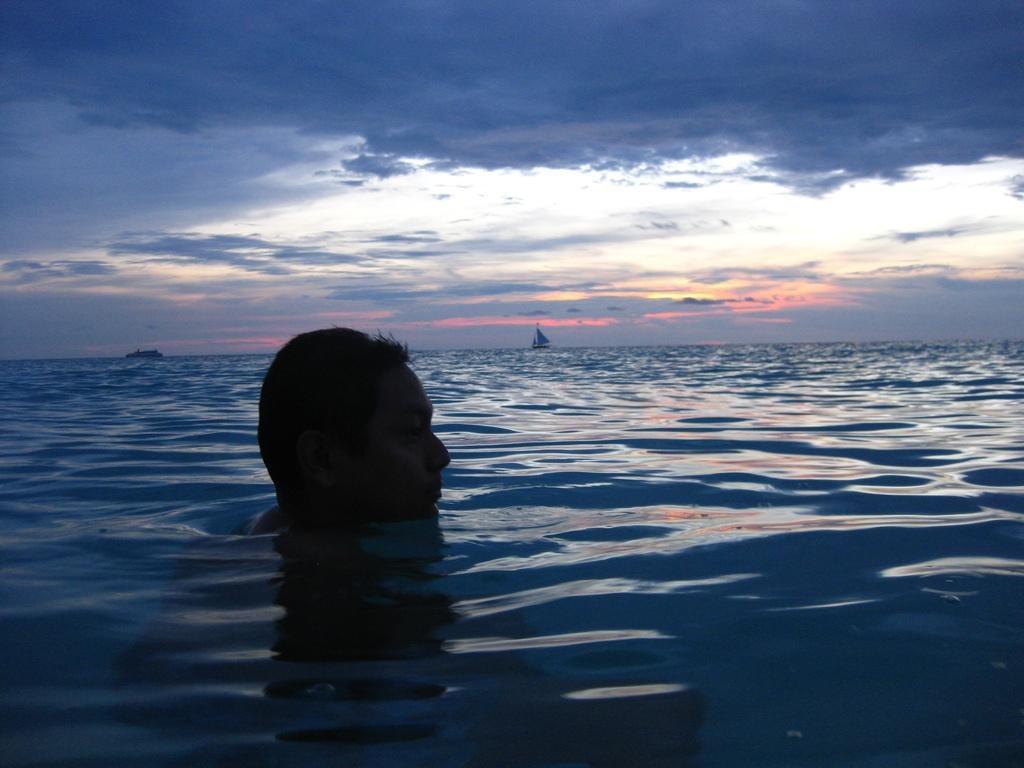What part of a person can be seen in the image? There is a person's head visible in the image. Where is the rest of the person's body located? The rest of the person's body is in the river. What else is present in the water besides the person's body? There are boats in the image. What can be seen in the background of the image? The sky is visible in the background of the image. Can you describe the loaf of bread that the stranger is holding in the image? There is no loaf of bread or stranger present in the image. Is there a rabbit visible in the image? There is no rabbit present in the image. 